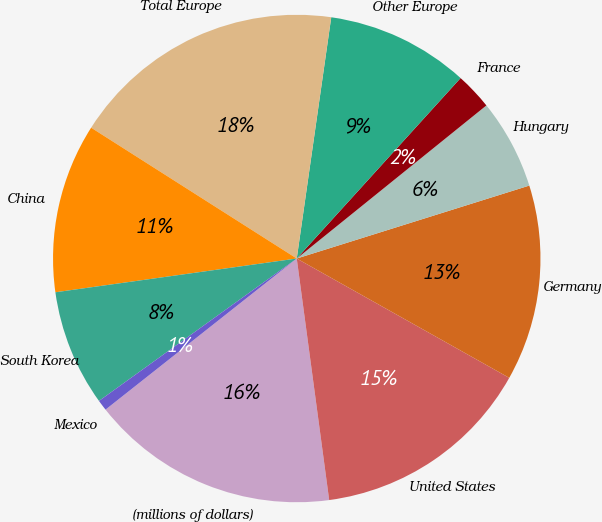Convert chart. <chart><loc_0><loc_0><loc_500><loc_500><pie_chart><fcel>(millions of dollars)<fcel>United States<fcel>Germany<fcel>Hungary<fcel>France<fcel>Other Europe<fcel>Total Europe<fcel>China<fcel>South Korea<fcel>Mexico<nl><fcel>16.48%<fcel>14.73%<fcel>12.98%<fcel>5.97%<fcel>2.46%<fcel>9.47%<fcel>18.24%<fcel>11.23%<fcel>7.72%<fcel>0.71%<nl></chart> 